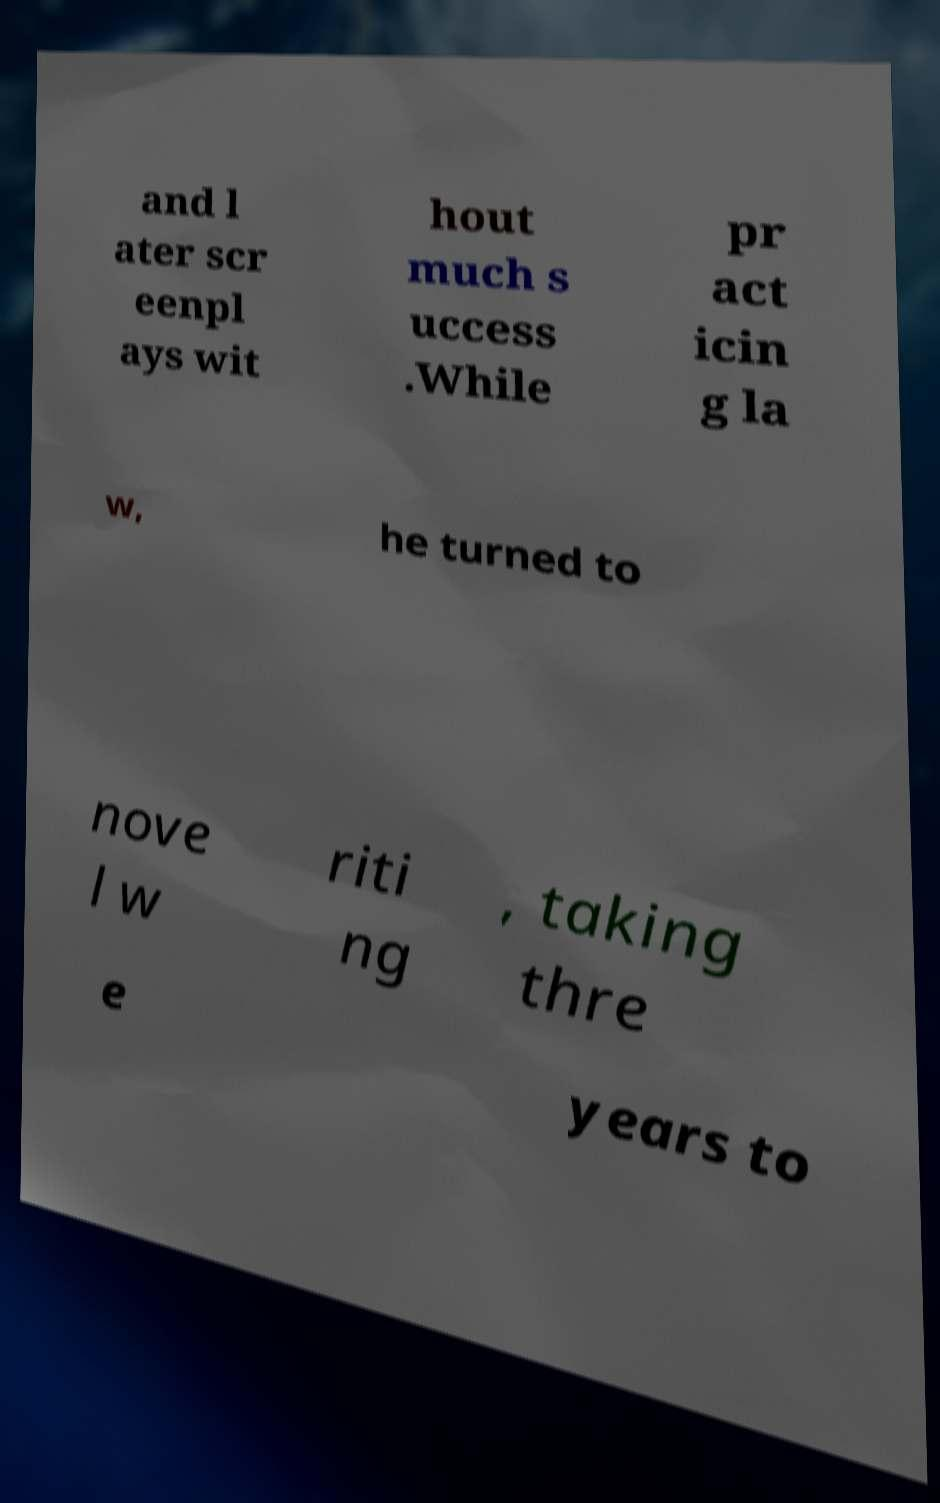Can you accurately transcribe the text from the provided image for me? and l ater scr eenpl ays wit hout much s uccess .While pr act icin g la w, he turned to nove l w riti ng , taking thre e years to 